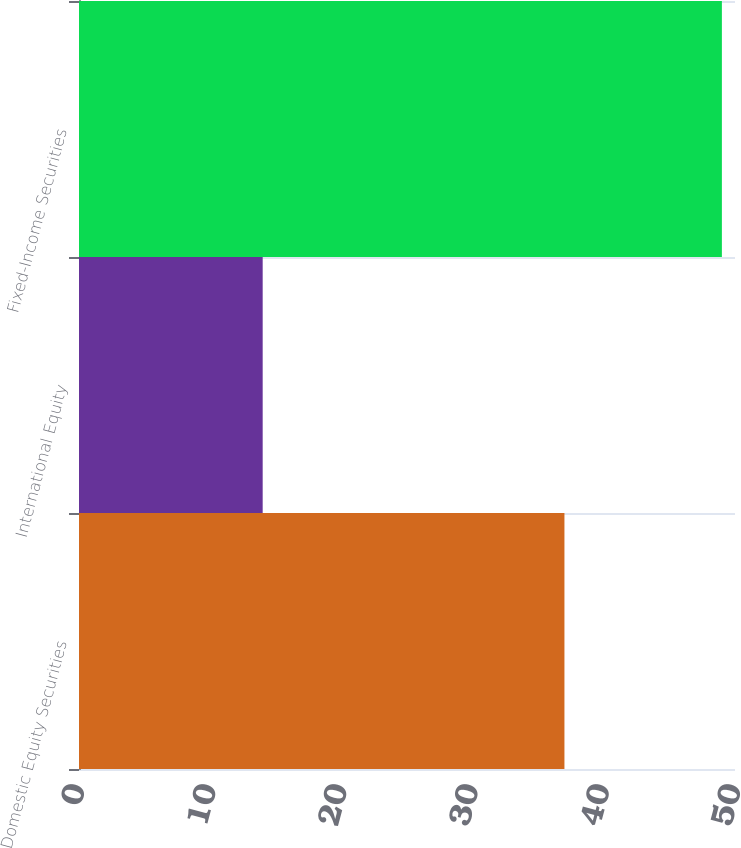<chart> <loc_0><loc_0><loc_500><loc_500><bar_chart><fcel>Domestic Equity Securities<fcel>International Equity<fcel>Fixed-Income Securities<nl><fcel>37<fcel>14<fcel>49<nl></chart> 